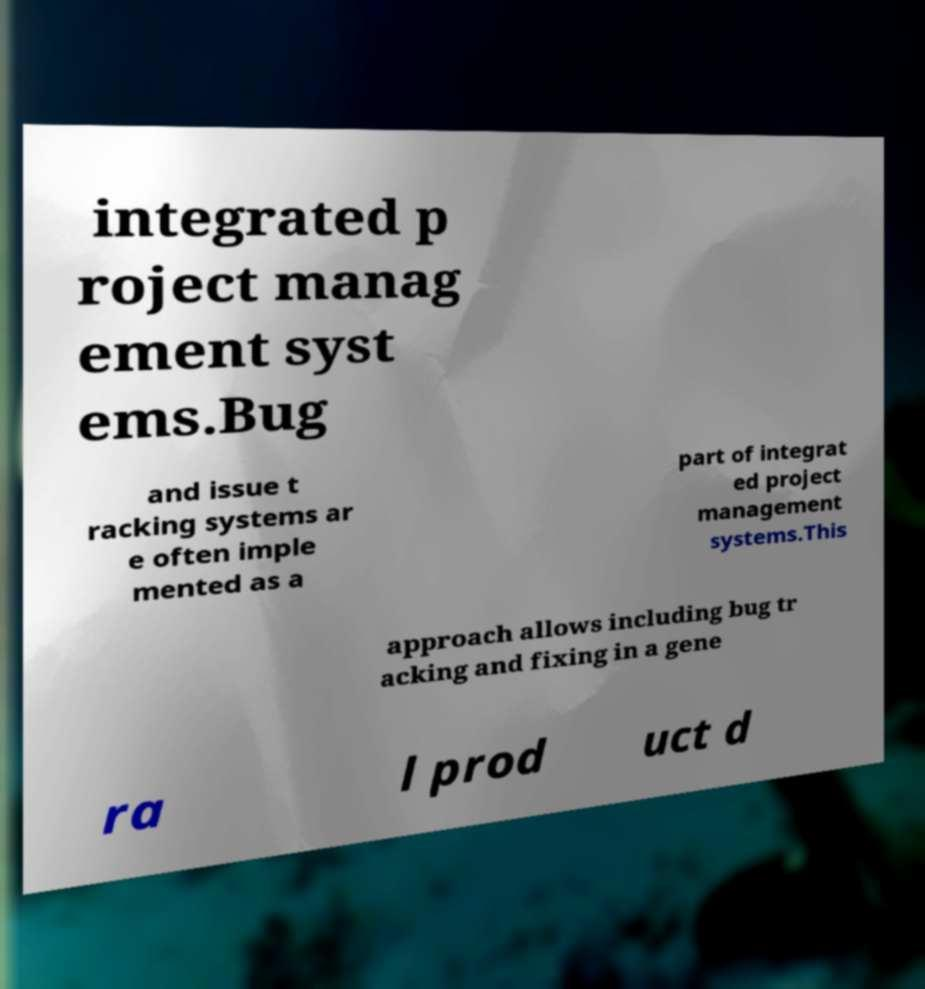Can you accurately transcribe the text from the provided image for me? integrated p roject manag ement syst ems.Bug and issue t racking systems ar e often imple mented as a part of integrat ed project management systems.This approach allows including bug tr acking and fixing in a gene ra l prod uct d 